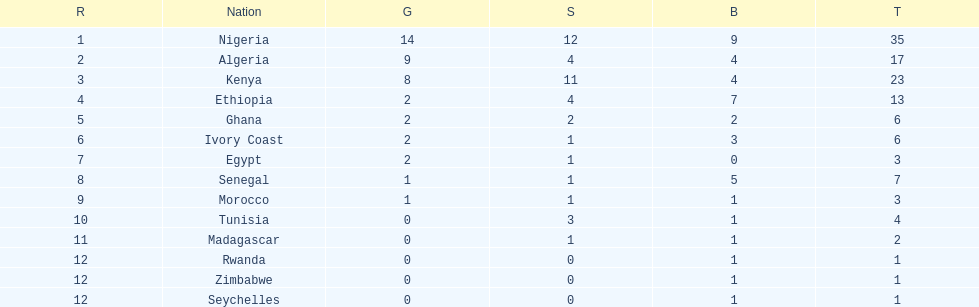The team with the most gold medals Nigeria. 